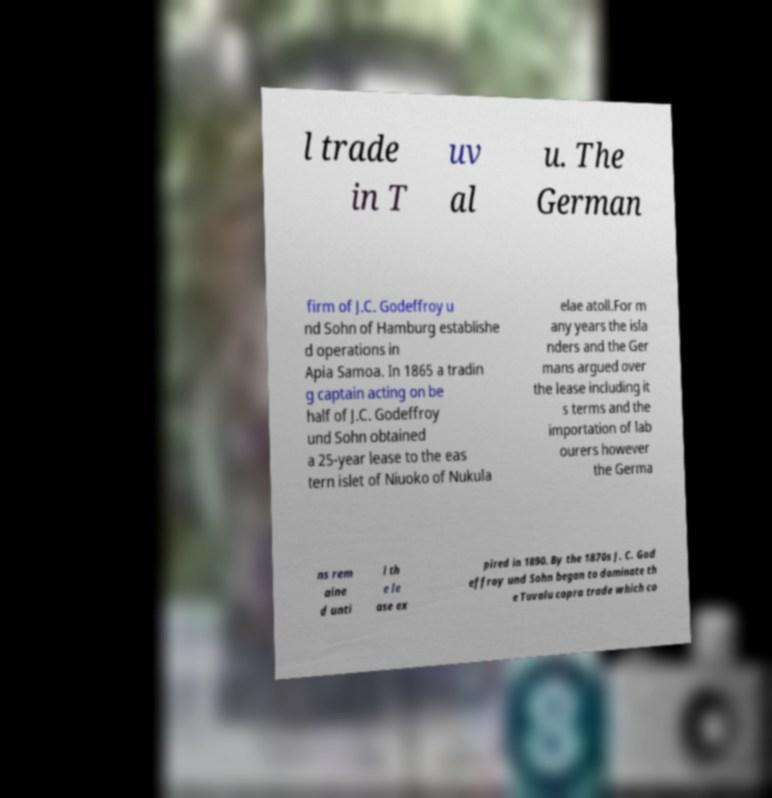Please identify and transcribe the text found in this image. l trade in T uv al u. The German firm of J.C. Godeffroy u nd Sohn of Hamburg establishe d operations in Apia Samoa. In 1865 a tradin g captain acting on be half of J.C. Godeffroy und Sohn obtained a 25-year lease to the eas tern islet of Niuoko of Nukula elae atoll.For m any years the isla nders and the Ger mans argued over the lease including it s terms and the importation of lab ourers however the Germa ns rem aine d unti l th e le ase ex pired in 1890. By the 1870s J. C. God effroy und Sohn began to dominate th e Tuvalu copra trade which co 